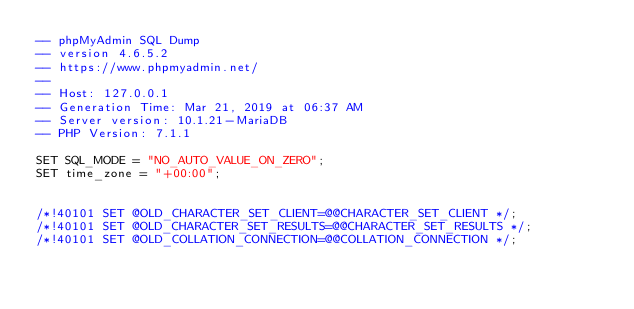Convert code to text. <code><loc_0><loc_0><loc_500><loc_500><_SQL_>-- phpMyAdmin SQL Dump
-- version 4.6.5.2
-- https://www.phpmyadmin.net/
--
-- Host: 127.0.0.1
-- Generation Time: Mar 21, 2019 at 06:37 AM
-- Server version: 10.1.21-MariaDB
-- PHP Version: 7.1.1

SET SQL_MODE = "NO_AUTO_VALUE_ON_ZERO";
SET time_zone = "+00:00";


/*!40101 SET @OLD_CHARACTER_SET_CLIENT=@@CHARACTER_SET_CLIENT */;
/*!40101 SET @OLD_CHARACTER_SET_RESULTS=@@CHARACTER_SET_RESULTS */;
/*!40101 SET @OLD_COLLATION_CONNECTION=@@COLLATION_CONNECTION */;</code> 